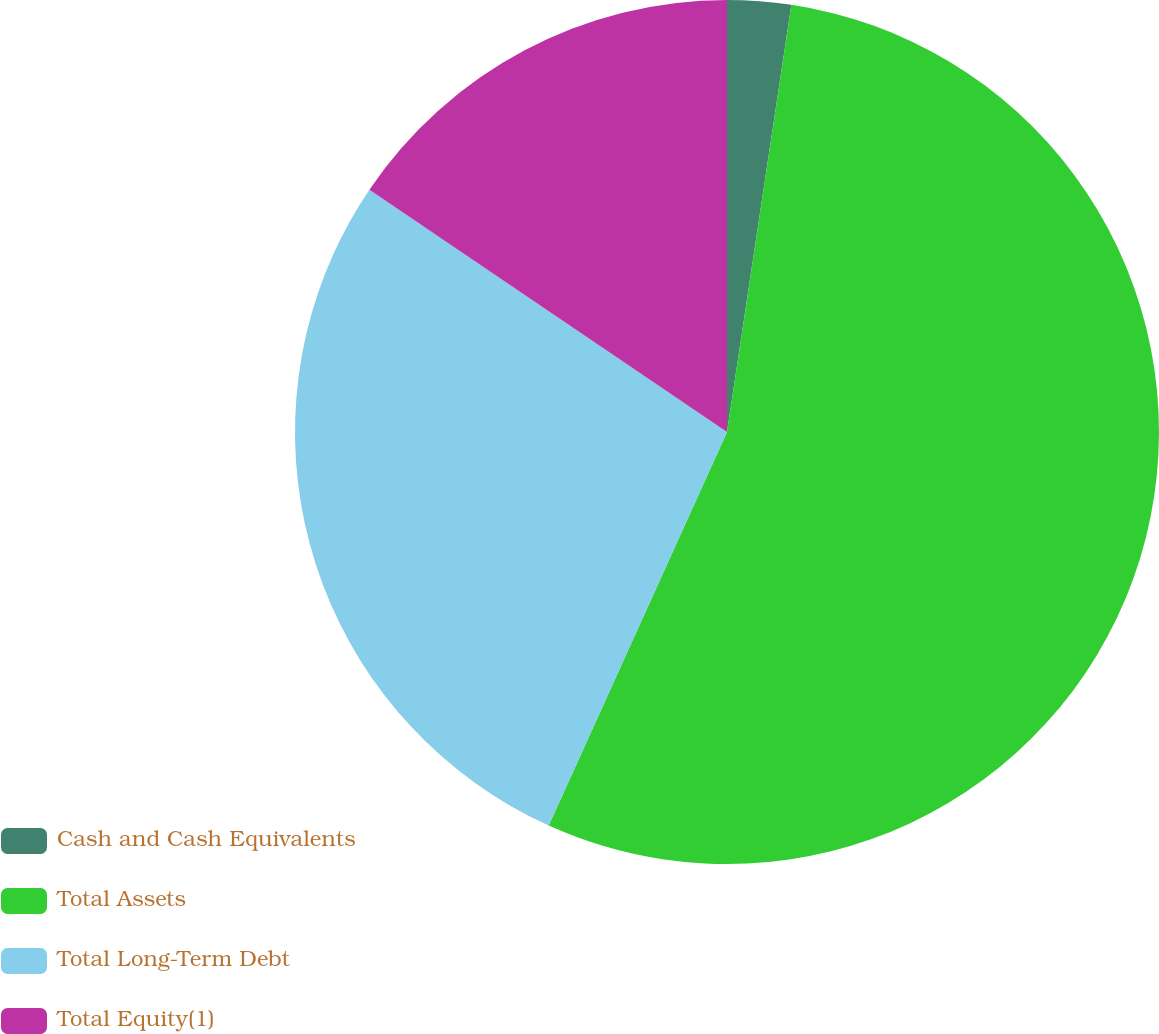Convert chart. <chart><loc_0><loc_0><loc_500><loc_500><pie_chart><fcel>Cash and Cash Equivalents<fcel>Total Assets<fcel>Total Long-Term Debt<fcel>Total Equity(1)<nl><fcel>2.38%<fcel>54.39%<fcel>27.71%<fcel>15.52%<nl></chart> 